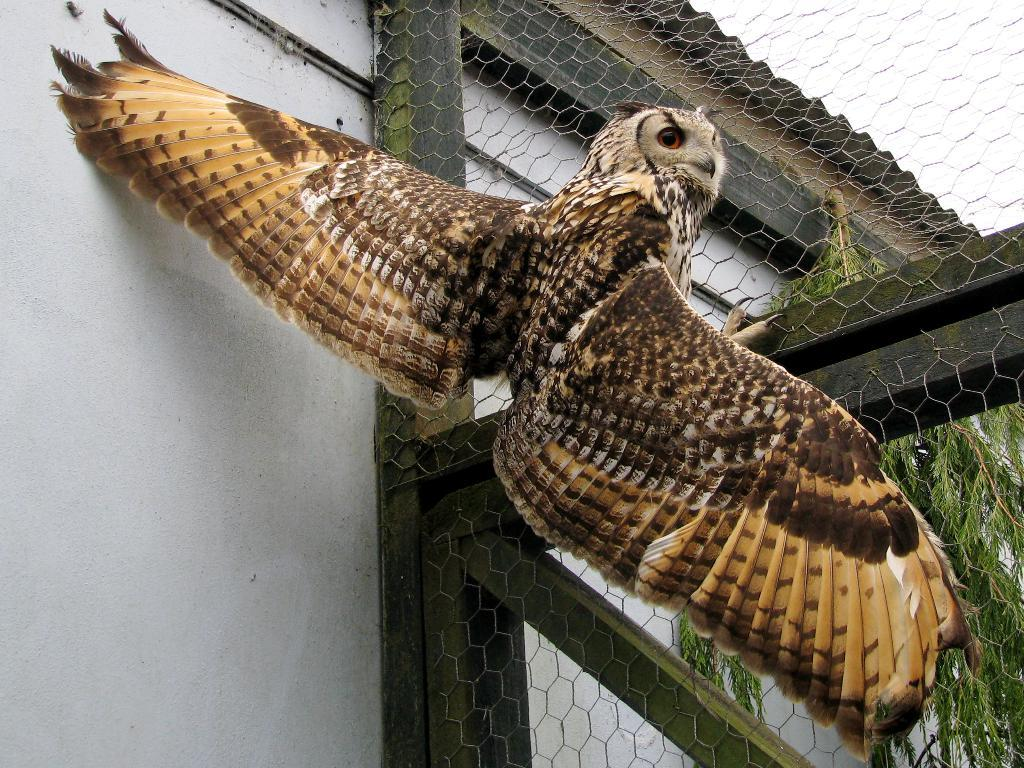What type of bird is in the picture? There is a brown owl in the picture. Where is the owl sitting? The owl is sitting on a net frame. What can be seen behind the owl? There is a white wall and a tree visible in the background. What stage of development is the carpenter at in the image? There is no carpenter present in the image; it features a brown owl sitting on a net frame. 